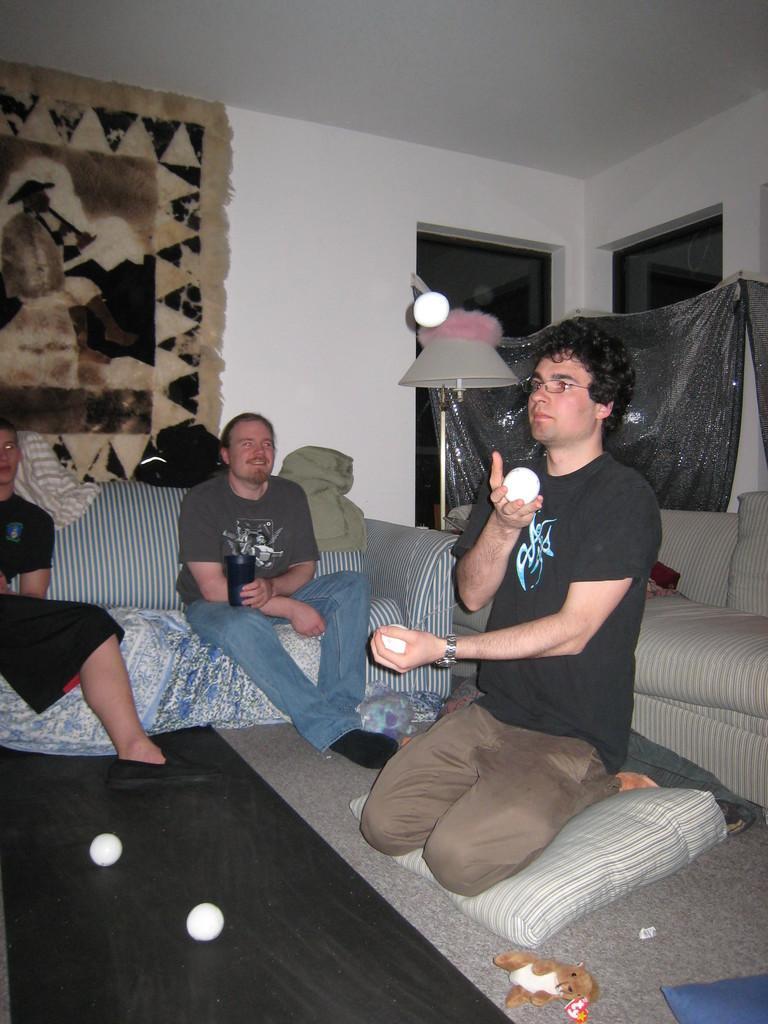Could you give a brief overview of what you see in this image? This picture describes about few people, few are seated on the sofa, on the right side of the image we can see a man, he is holding few balls in his hands, in front of him we can find a toy, in the background we can find few lights and a carpet on the wall. 